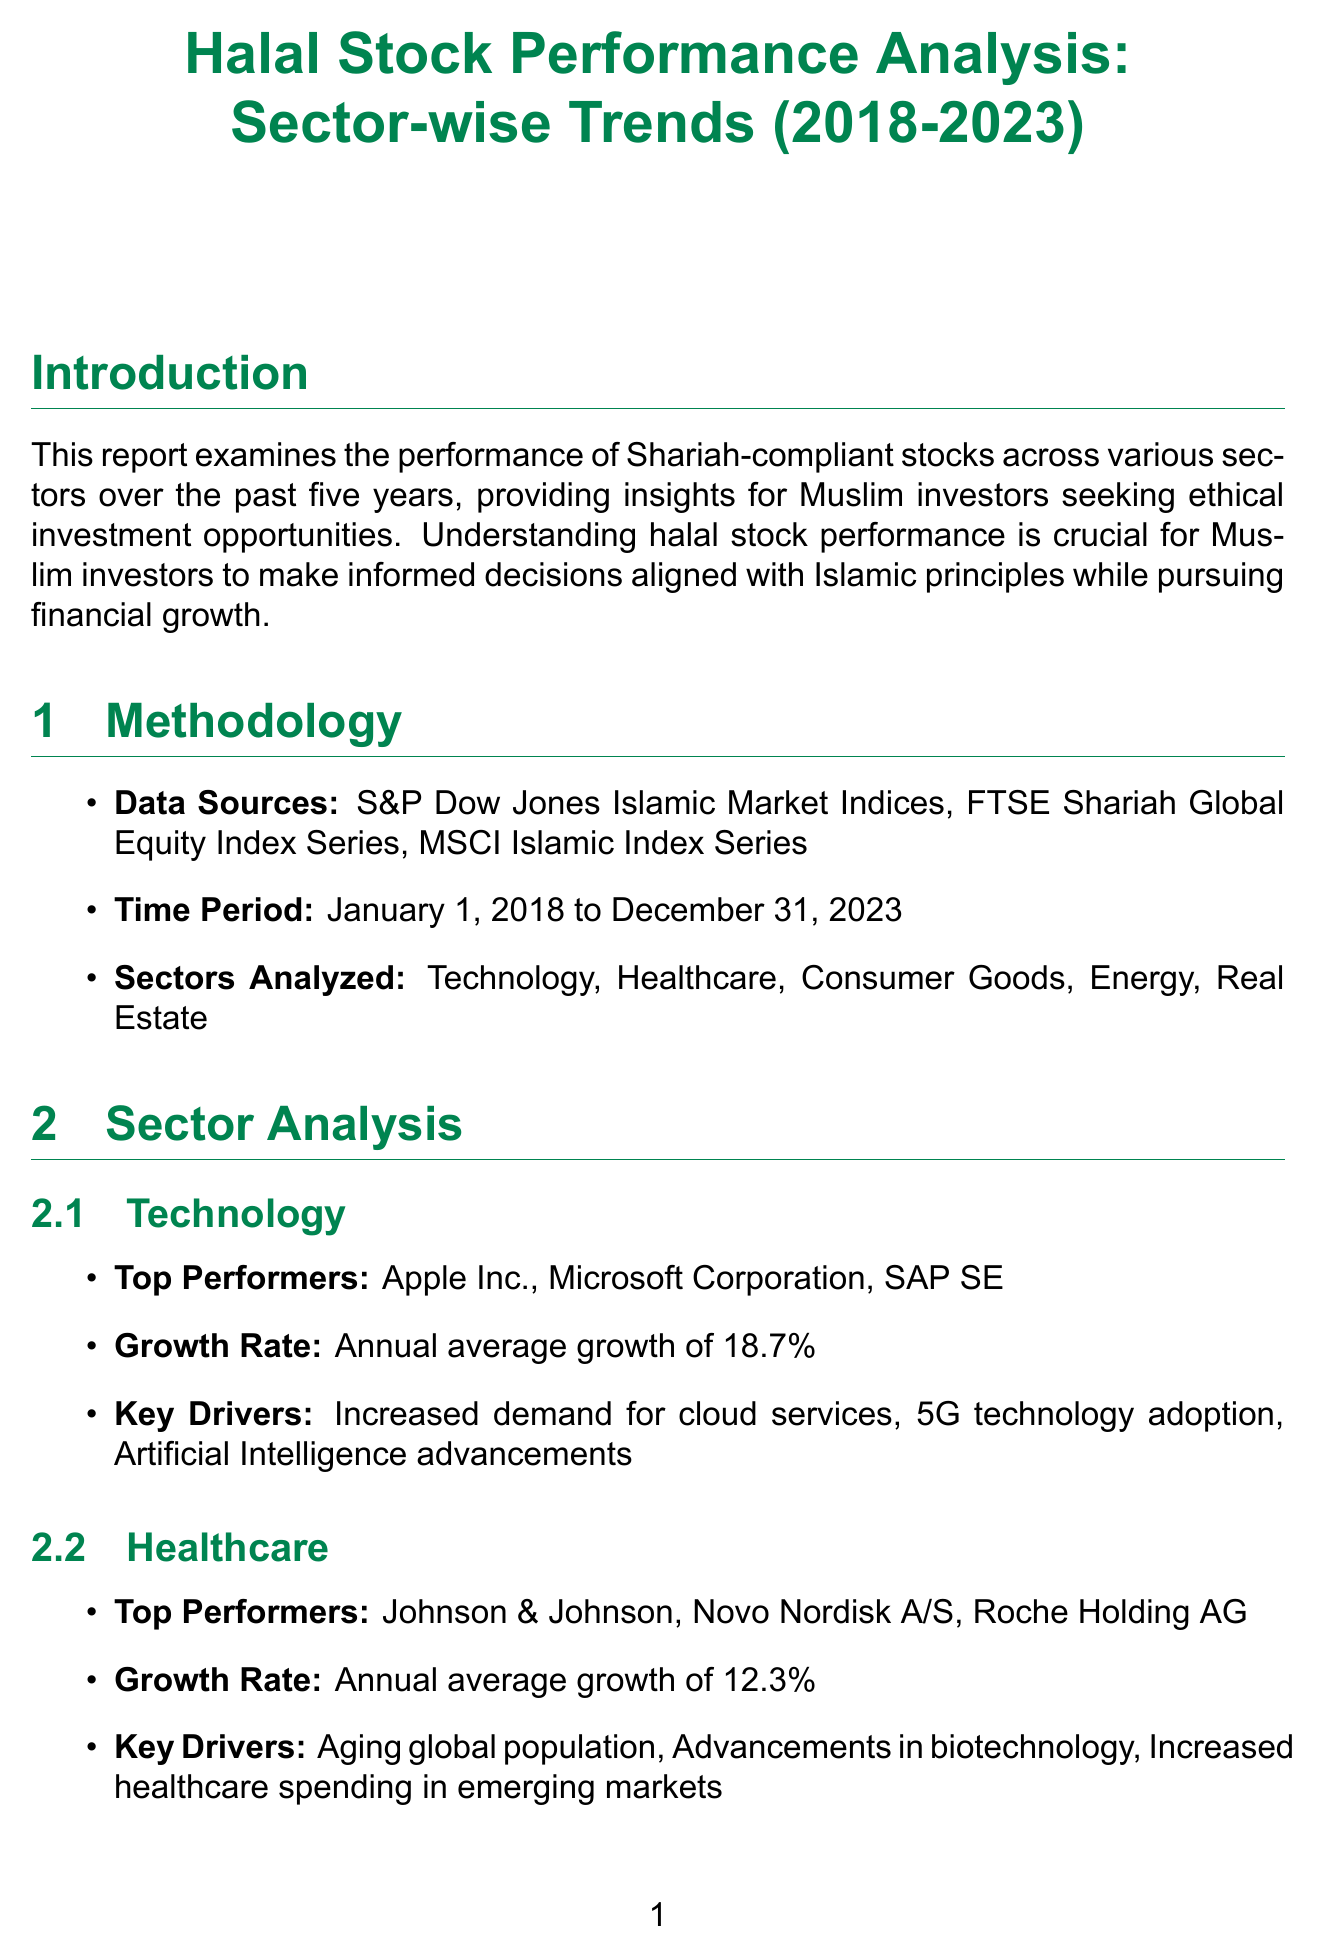What is the duration of the study? The report examines performance over the five-year period from January 1, 2018 to December 31, 2023.
Answer: five years Which sector had the highest annual average growth rate? The Technology sector led with an annual average growth of 18.7%.
Answer: Technology Who are the top performers in the Healthcare sector? Specifically, Johnson & Johnson, Novo Nordisk A/S, and Roche Holding AG are named as top performers.
Answer: Johnson & Johnson, Novo Nordisk A/S, Roche Holding AG What was the growth rate for Consumer Goods? The report states that Consumer Goods had an annual average growth of 7.5%.
Answer: 7.5% Which sector experienced the highest volatility? The Energy sector is noted for experiencing the highest volatility based on market performance.
Answer: Energy What key driver is mentioned for the Technology sector? Increased demand for cloud services is identified as a key driver for the Technology sector's performance.
Answer: Increased demand for cloud services What does the report suggest about the future outlook of halal stocks? It projects positive growth prospects with a focus on ESG factors that align with Islamic principles.
Answer: Positive growth prospects How many Islamic finance institutions are listed in additional resources? Two institutions are mentioned in the additional resources section of the report.
Answer: two 